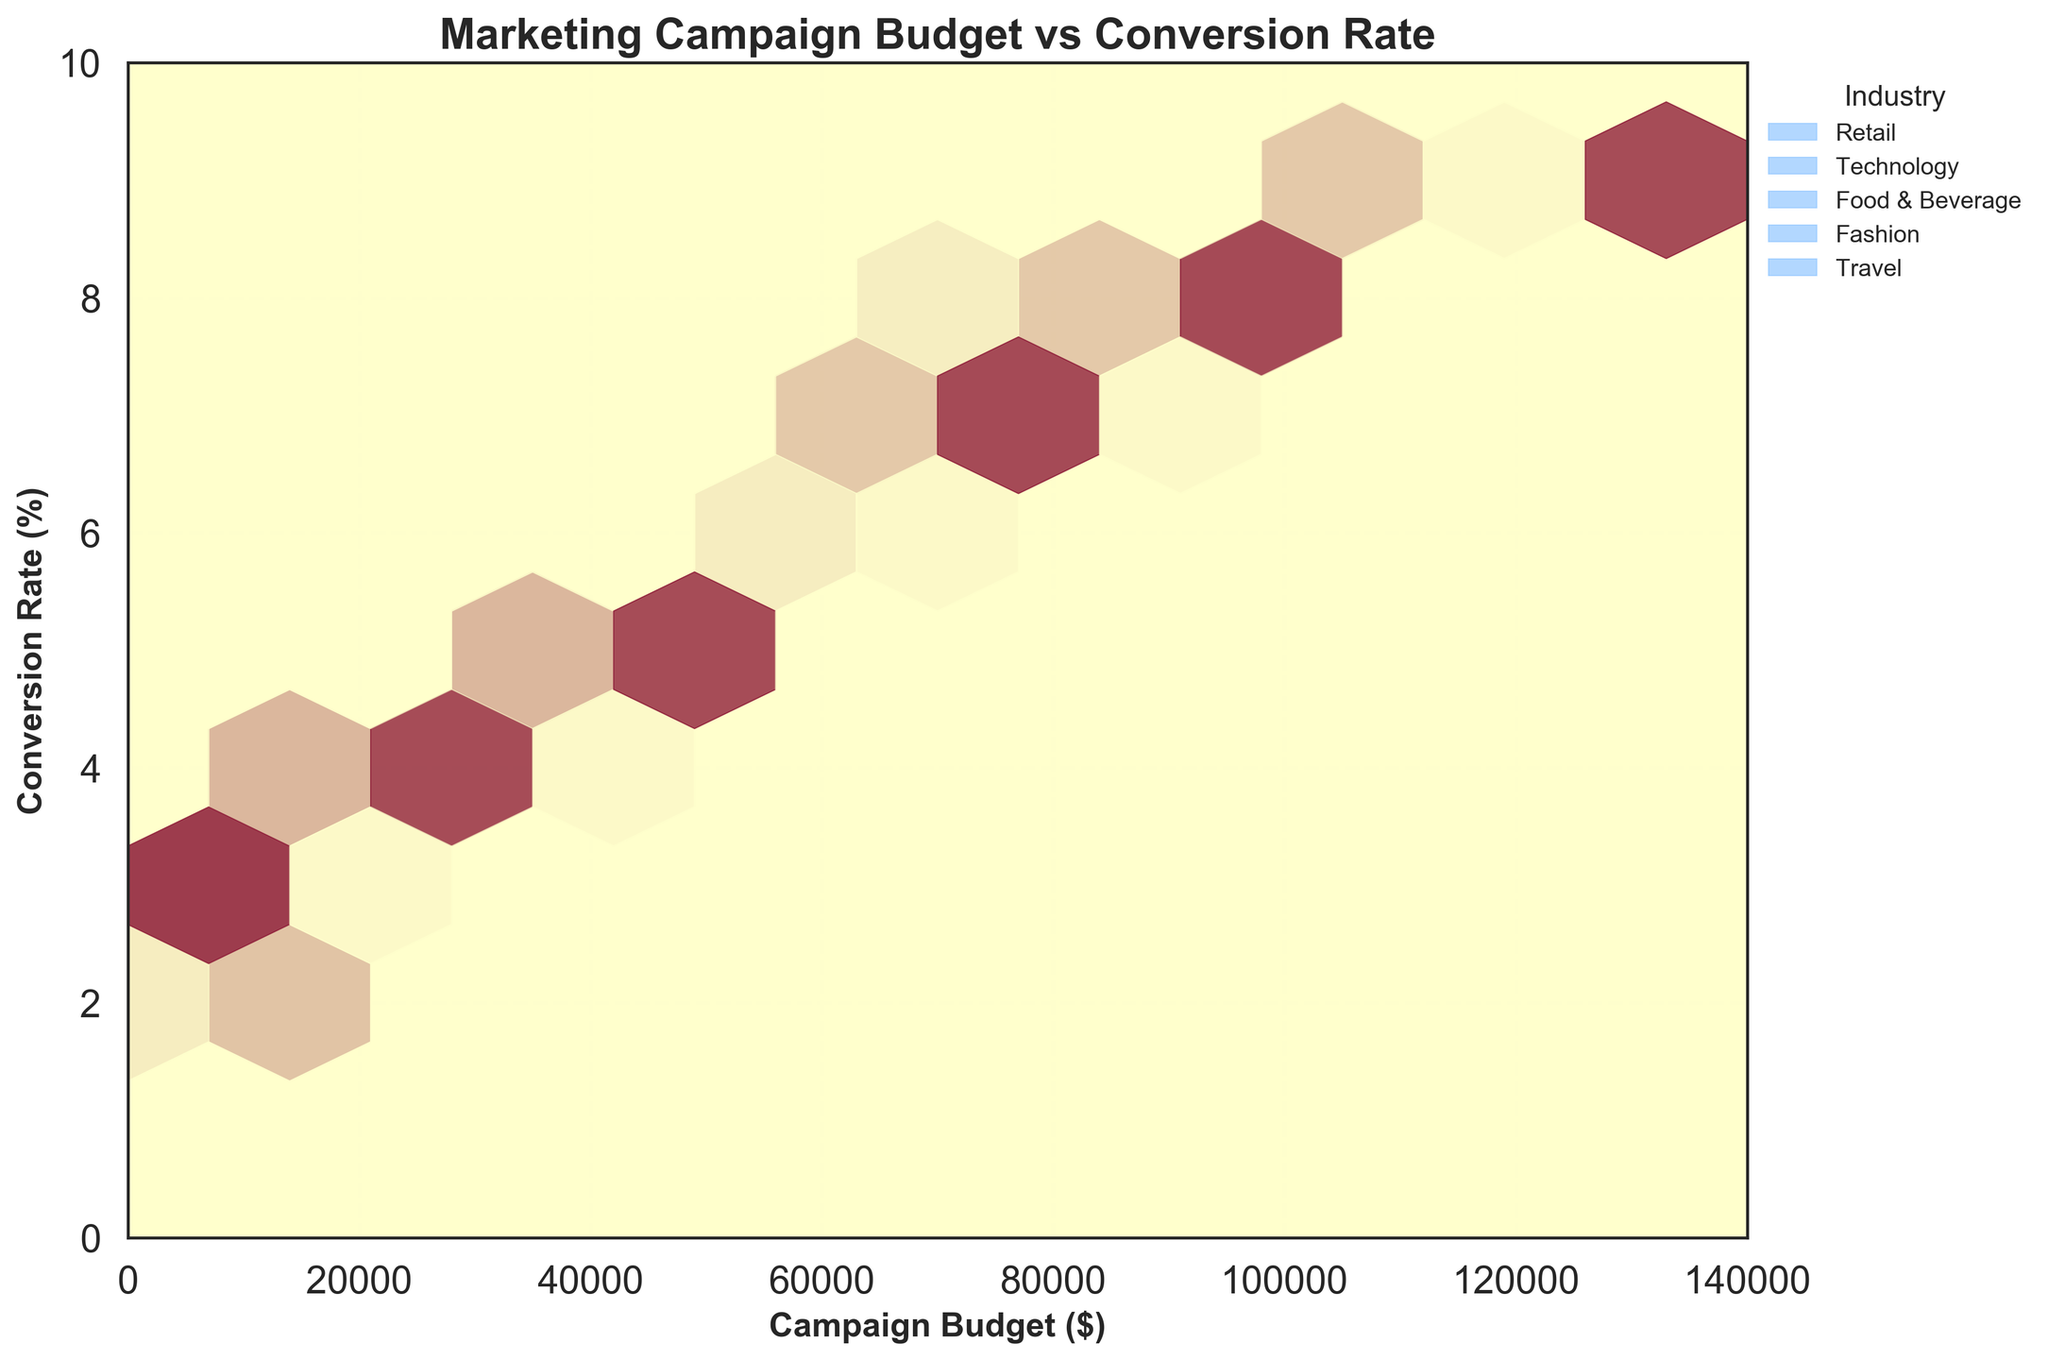What is the title of the plot? The title of the plot is prominently displayed at the top of the figure in bold text.
Answer: Marketing Campaign Budget vs Conversion Rate What are the x and y axes labels? The labels for the x and y axes are the textual elements next to the respective axes, indicating what each axis represents.
Answer: Campaign Budget ($) and Conversion Rate (%) Which industry shows the highest conversion rate overall? By looking at the color-coded legend and comparing the heights of hexagons along the y-axis, it's clear that the "Travel" industry reaches the highest conversion rate.
Answer: Travel What's the approximate conversion rate for the "Retail" industry with a budget of $50,000? By locating the $50,000 mark on the x-axis, then moving up vertically to the highest density hexagon within the color corresponding to "Retail", you find the y-axis value.
Answer: 6.2% How many industries are compared in the plot? By counting the different colors in the legend on the right side of the plot, you can tally the number of unique industries.
Answer: 5 Which industry appears to have the most spread in conversion rates? By observing the range of y-axis values for each color, it appears that both the "Retail" and "Travel" industries cover a wide range of conversion rates, but "Travel" spans from about 2.9% to 9.2%.
Answer: Travel Which industry has the lowest conversion rates for budgets under $10,000? By examining the hexagons in the $0-$10,000 range on the x-axis, then comparing the colors. "Food & Beverage" and "Technology" show lower conversion rates near 1.5%-1.8%.
Answer: Food & Beverage Compare the conversion rates for "Fashion" and "Technology" when the budget is around $40,000. Which one is higher? By looking around the $40,000 value on the x-axis and comparing the relevant hexagons' vertical positions for "Fashion" and "Technology". Fashion has a higher rate at 5.2% compared to Technology at 4.5%.
Answer: Fashion Which industry achieves a conversion rate of 8.5%? By tracing horizontally along the y-axis from the 8.5% mark and noting the color of the matching hexagon. "Technology" reaches an 8.5% conversion rate.
Answer: Technology What is the range of conversion rates for a $75,000 budget across all industries? By looking vertically from the $75,000 mark on the x-axis to see the spread of hexagons from different industries. You find rates range from 7.1% (Travel) to 7.8% (Food & Beverage).
Answer: 7.1% to 7.8% 